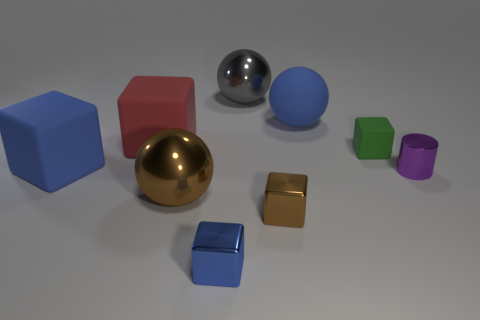Is there anything else that is the same shape as the small purple object?
Give a very brief answer. No. There is a big metal ball left of the small blue metallic object; does it have the same color as the tiny metallic cube that is on the right side of the blue metal object?
Your answer should be very brief. Yes. Is there a cube that has the same color as the big rubber sphere?
Your response must be concise. Yes. Is there a big block made of the same material as the brown ball?
Offer a terse response. No. There is a small purple object; what shape is it?
Your response must be concise. Cylinder. What is the color of the other ball that is the same material as the gray ball?
Offer a terse response. Brown. How many blue objects are big rubber things or tiny cylinders?
Your answer should be compact. 2. Is the number of big matte balls greater than the number of brown things?
Ensure brevity in your answer.  No. How many things are big spheres that are behind the small green cube or small blocks that are on the right side of the big gray ball?
Provide a succinct answer. 4. There is a rubber ball that is the same size as the red thing; what is its color?
Provide a short and direct response. Blue. 